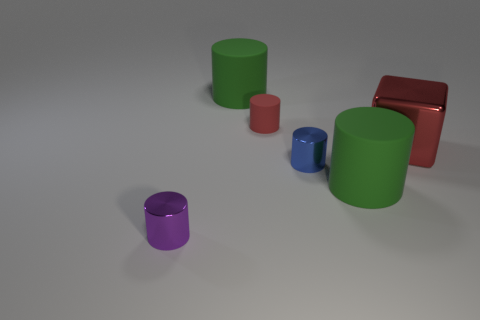Subtract all small blue shiny cylinders. How many cylinders are left? 4 Subtract all blue cylinders. How many cylinders are left? 4 Add 1 purple shiny cylinders. How many objects exist? 7 Subtract all cubes. How many objects are left? 5 Subtract all cyan cylinders. Subtract all yellow balls. How many cylinders are left? 5 Subtract all green blocks. How many green cylinders are left? 2 Subtract all purple shiny cylinders. Subtract all brown shiny spheres. How many objects are left? 5 Add 1 red objects. How many red objects are left? 3 Add 1 red things. How many red things exist? 3 Subtract 0 blue balls. How many objects are left? 6 